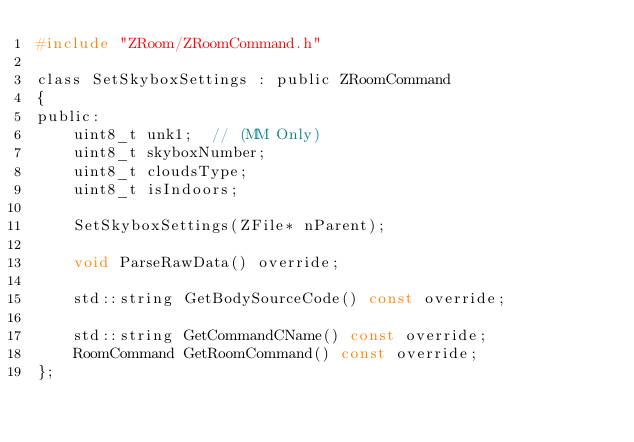<code> <loc_0><loc_0><loc_500><loc_500><_C_>#include "ZRoom/ZRoomCommand.h"

class SetSkyboxSettings : public ZRoomCommand
{
public:
	uint8_t unk1;  // (MM Only)
	uint8_t skyboxNumber;
	uint8_t cloudsType;
	uint8_t isIndoors;

	SetSkyboxSettings(ZFile* nParent);

	void ParseRawData() override;

	std::string GetBodySourceCode() const override;

	std::string GetCommandCName() const override;
	RoomCommand GetRoomCommand() const override;
};
</code> 